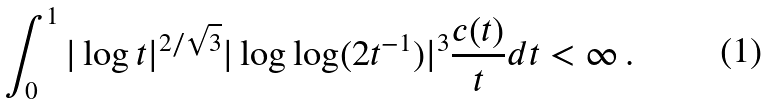Convert formula to latex. <formula><loc_0><loc_0><loc_500><loc_500>\int _ { 0 } ^ { 1 } | \log t | ^ { 2 / { \sqrt { 3 } } } | \log \log ( 2 t ^ { - 1 } ) | ^ { 3 } \frac { c ( t ) } { t } d t < \infty \, .</formula> 